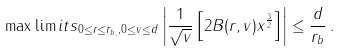Convert formula to latex. <formula><loc_0><loc_0><loc_500><loc_500>\max \lim i t s _ { 0 \leq r \leq r _ { b , } , 0 \leq v \leq d } \left | \frac { 1 } { \sqrt { v } } \left [ 2 B ( r , v ) x ^ { \frac { 3 } { 2 } } \right ] \right | \leq \frac { d } { r _ { b } } \, .</formula> 